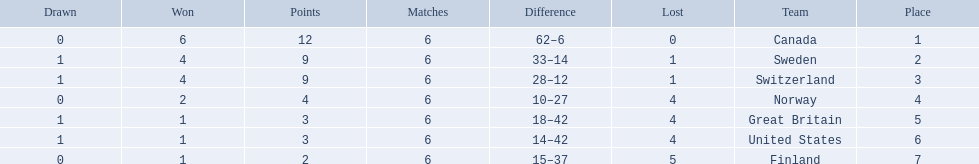Which are the two countries? Switzerland, Great Britain. What were the point totals for each of these countries? 9, 3. Of these point totals, which is better? 9. Which country earned this point total? Switzerland. 